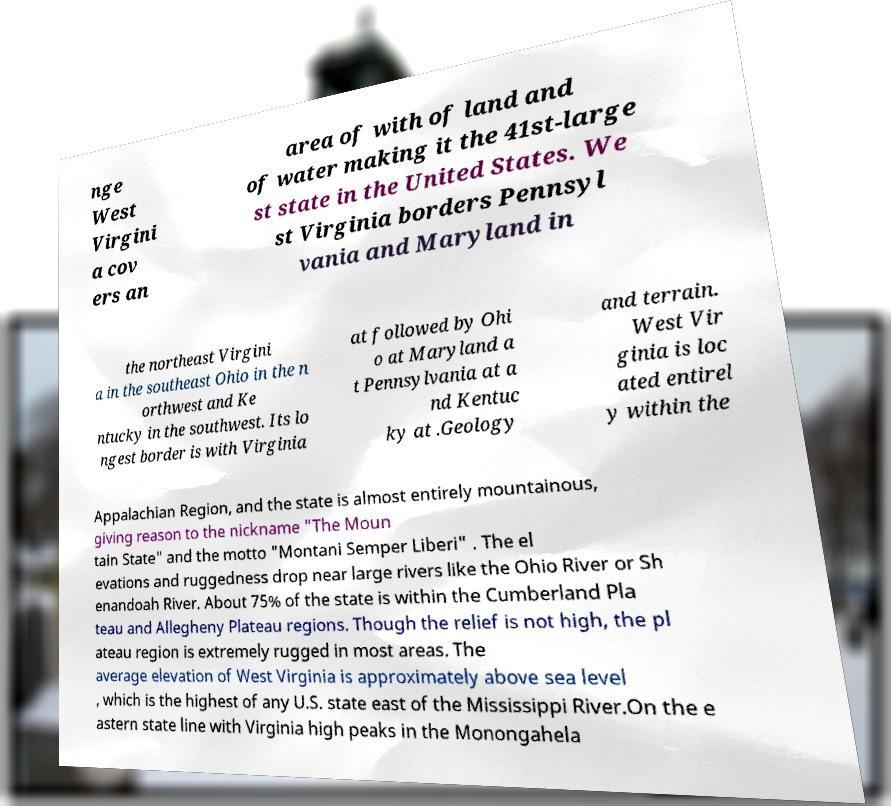There's text embedded in this image that I need extracted. Can you transcribe it verbatim? nge West Virgini a cov ers an area of with of land and of water making it the 41st-large st state in the United States. We st Virginia borders Pennsyl vania and Maryland in the northeast Virgini a in the southeast Ohio in the n orthwest and Ke ntucky in the southwest. Its lo ngest border is with Virginia at followed by Ohi o at Maryland a t Pennsylvania at a nd Kentuc ky at .Geology and terrain. West Vir ginia is loc ated entirel y within the Appalachian Region, and the state is almost entirely mountainous, giving reason to the nickname "The Moun tain State" and the motto "Montani Semper Liberi" . The el evations and ruggedness drop near large rivers like the Ohio River or Sh enandoah River. About 75% of the state is within the Cumberland Pla teau and Allegheny Plateau regions. Though the relief is not high, the pl ateau region is extremely rugged in most areas. The average elevation of West Virginia is approximately above sea level , which is the highest of any U.S. state east of the Mississippi River.On the e astern state line with Virginia high peaks in the Monongahela 